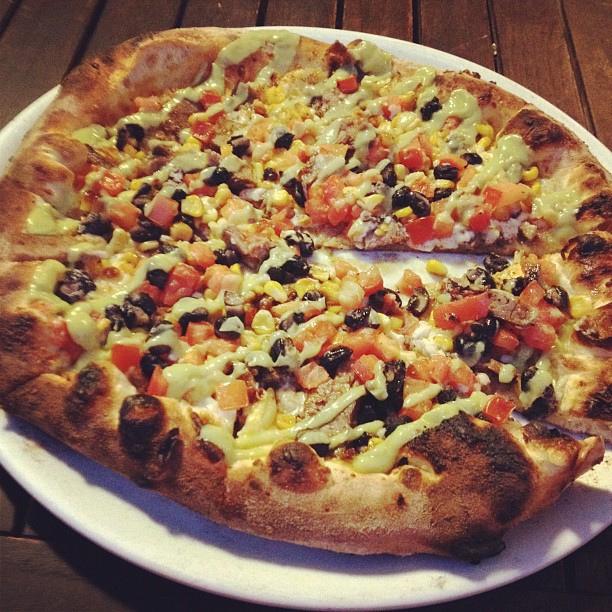How many pizzas on the table?
Short answer required. 1. How many toppings does this pizza have on it's crust?
Quick response, please. 4. Does the pizza look burnt?
Concise answer only. Yes. Is there sauce on the pizza?
Concise answer only. Yes. What is the pizza on?
Give a very brief answer. Plate. What topping is on the pizza?
Keep it brief. Tomatoes. 